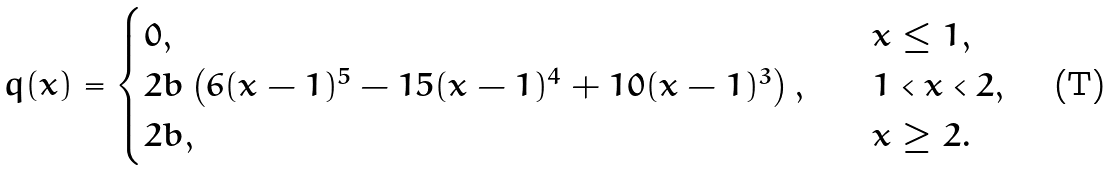<formula> <loc_0><loc_0><loc_500><loc_500>q ( x ) = \begin{cases} 0 , & \quad x \leq 1 , \\ 2 b \left ( 6 ( x - 1 ) ^ { 5 } - 1 5 ( x - 1 ) ^ { 4 } + 1 0 ( x - 1 ) ^ { 3 } \right ) , & \quad 1 < x < 2 , \\ 2 b , & \quad x \geq 2 . \end{cases}</formula> 